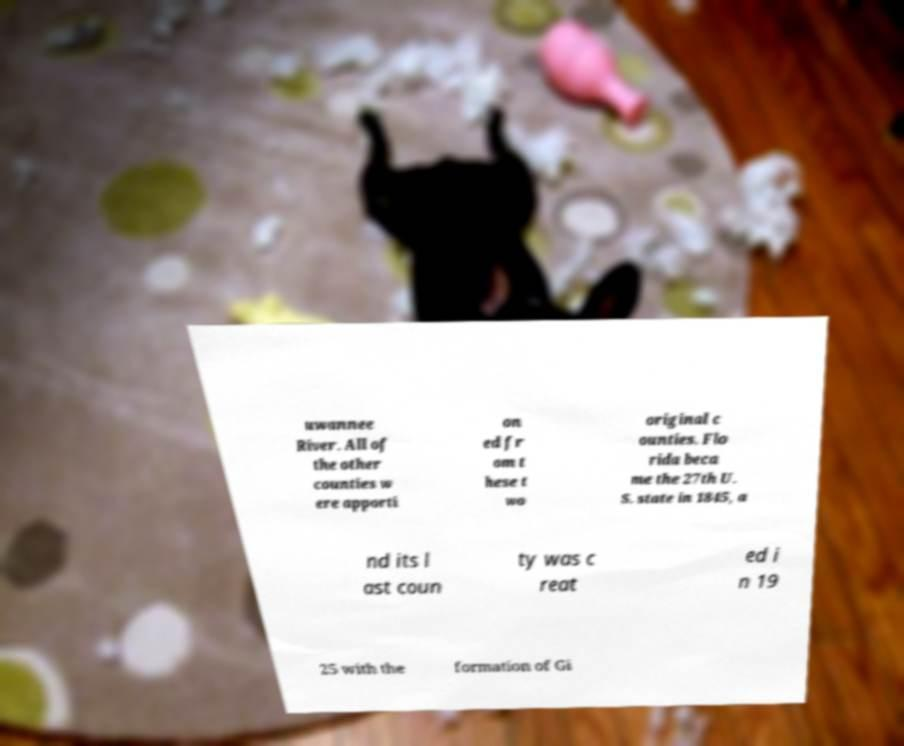Could you extract and type out the text from this image? uwannee River. All of the other counties w ere apporti on ed fr om t hese t wo original c ounties. Flo rida beca me the 27th U. S. state in 1845, a nd its l ast coun ty was c reat ed i n 19 25 with the formation of Gi 